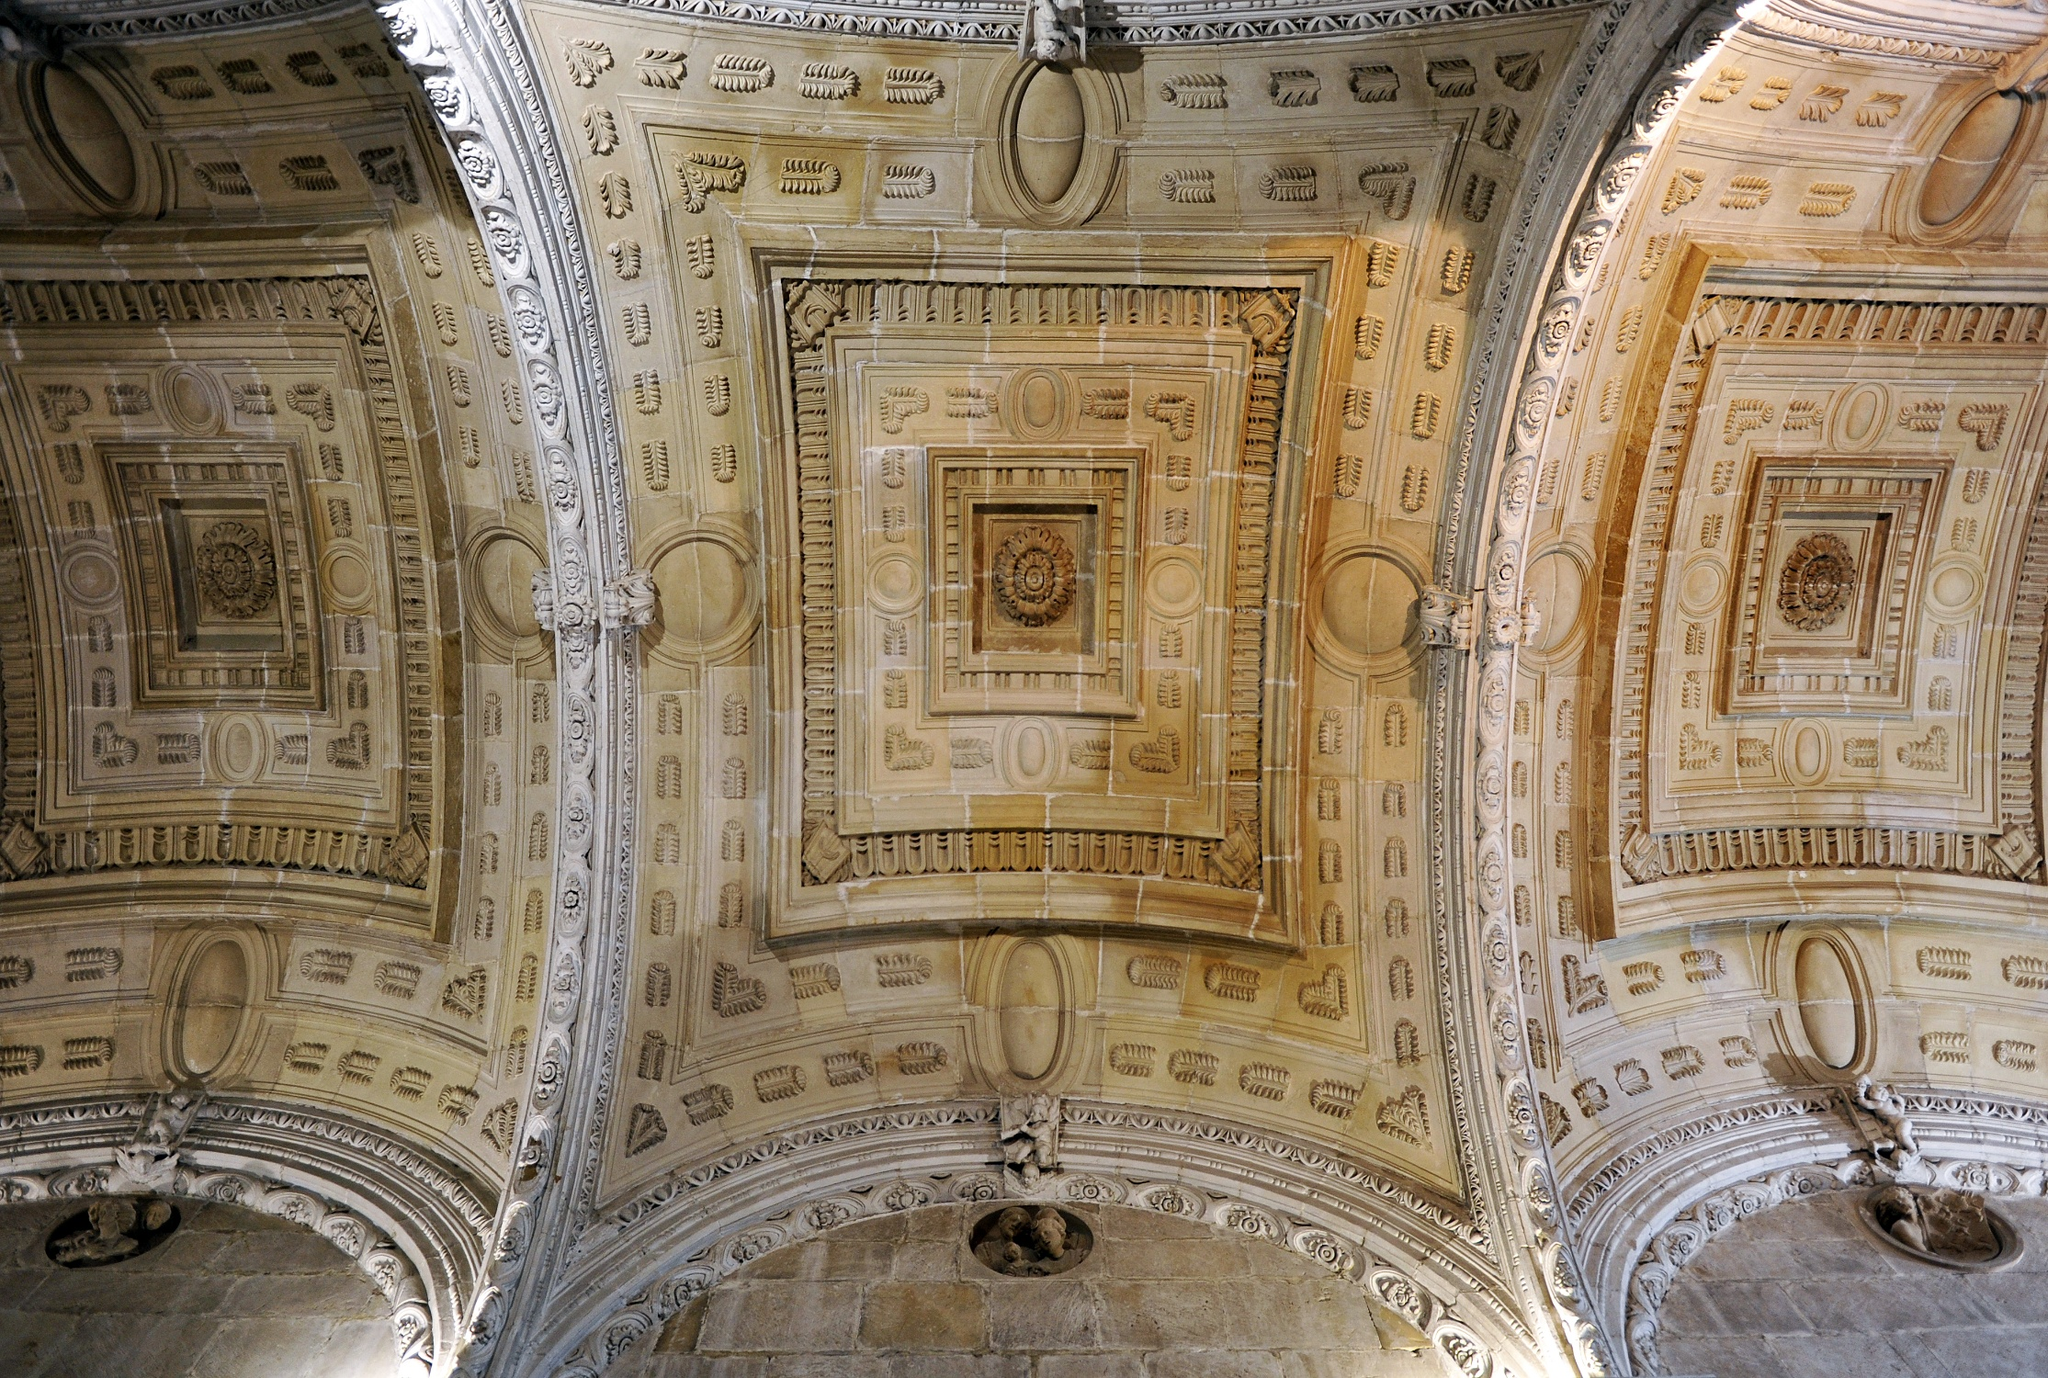Analyze the image in a comprehensive and detailed manner. The image showcases the architectural grandeur of a ceiling with detailed craftsmanship. The perspective is from below, giving an immersive view of the ceiling adorned with intricate geometric patterns and elaborate designs. The symmetrical layout emphasizes the skill of the artisans who created it. Predominantly, the colors are shades of beige and white, with some sections illuminated by gentle lighting, adding depth to the texture. The arches on the sides frame the ceiling, providing a sense of architectural unity. Each element, from the decorative motifs to the structural details, contributes to an overall sense of opulent elegance. This ceiling, potentially part of a historic building, reflects a deep appreciation for art and symmetry characteristic of the period it was built in. 